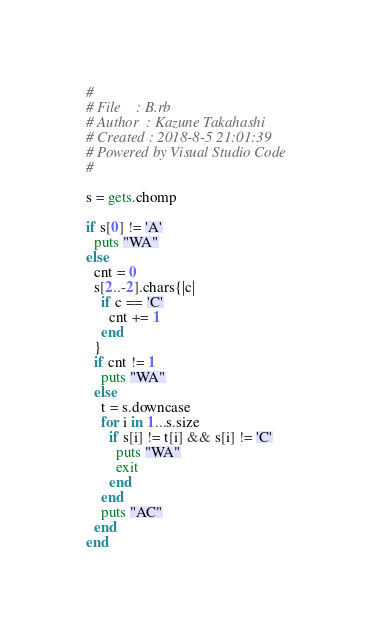Convert code to text. <code><loc_0><loc_0><loc_500><loc_500><_Ruby_>#
# File    : B.rb
# Author  : Kazune Takahashi
# Created : 2018-8-5 21:01:39
# Powered by Visual Studio Code
#

s = gets.chomp

if s[0] != 'A'
  puts "WA"
else
  cnt = 0
  s[2..-2].chars{|c|
    if c == 'C'
      cnt += 1
    end
  }
  if cnt != 1
    puts "WA"
  else
    t = s.downcase
    for i in 1...s.size
      if s[i] != t[i] && s[i] != 'C'
        puts "WA"
        exit
      end
    end
    puts "AC"
  end
end
</code> 